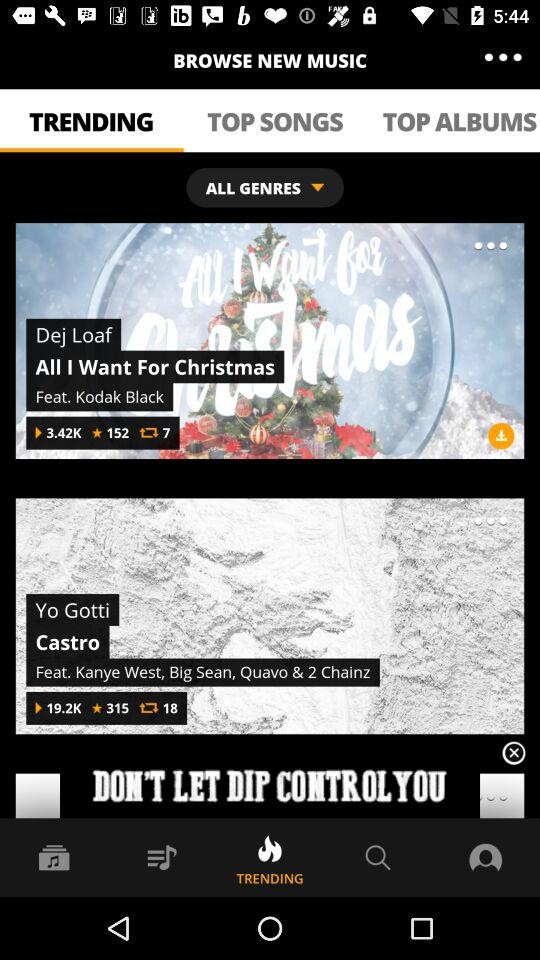How many favorites are there for Castro? There are 315 favorites. 